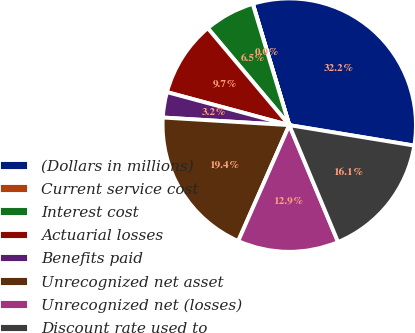Convert chart to OTSL. <chart><loc_0><loc_0><loc_500><loc_500><pie_chart><fcel>(Dollars in millions)<fcel>Current service cost<fcel>Interest cost<fcel>Actuarial losses<fcel>Benefits paid<fcel>Unrecognized net asset<fcel>Unrecognized net (losses)<fcel>Discount rate used to<nl><fcel>32.23%<fcel>0.02%<fcel>6.46%<fcel>9.68%<fcel>3.24%<fcel>19.35%<fcel>12.9%<fcel>16.12%<nl></chart> 